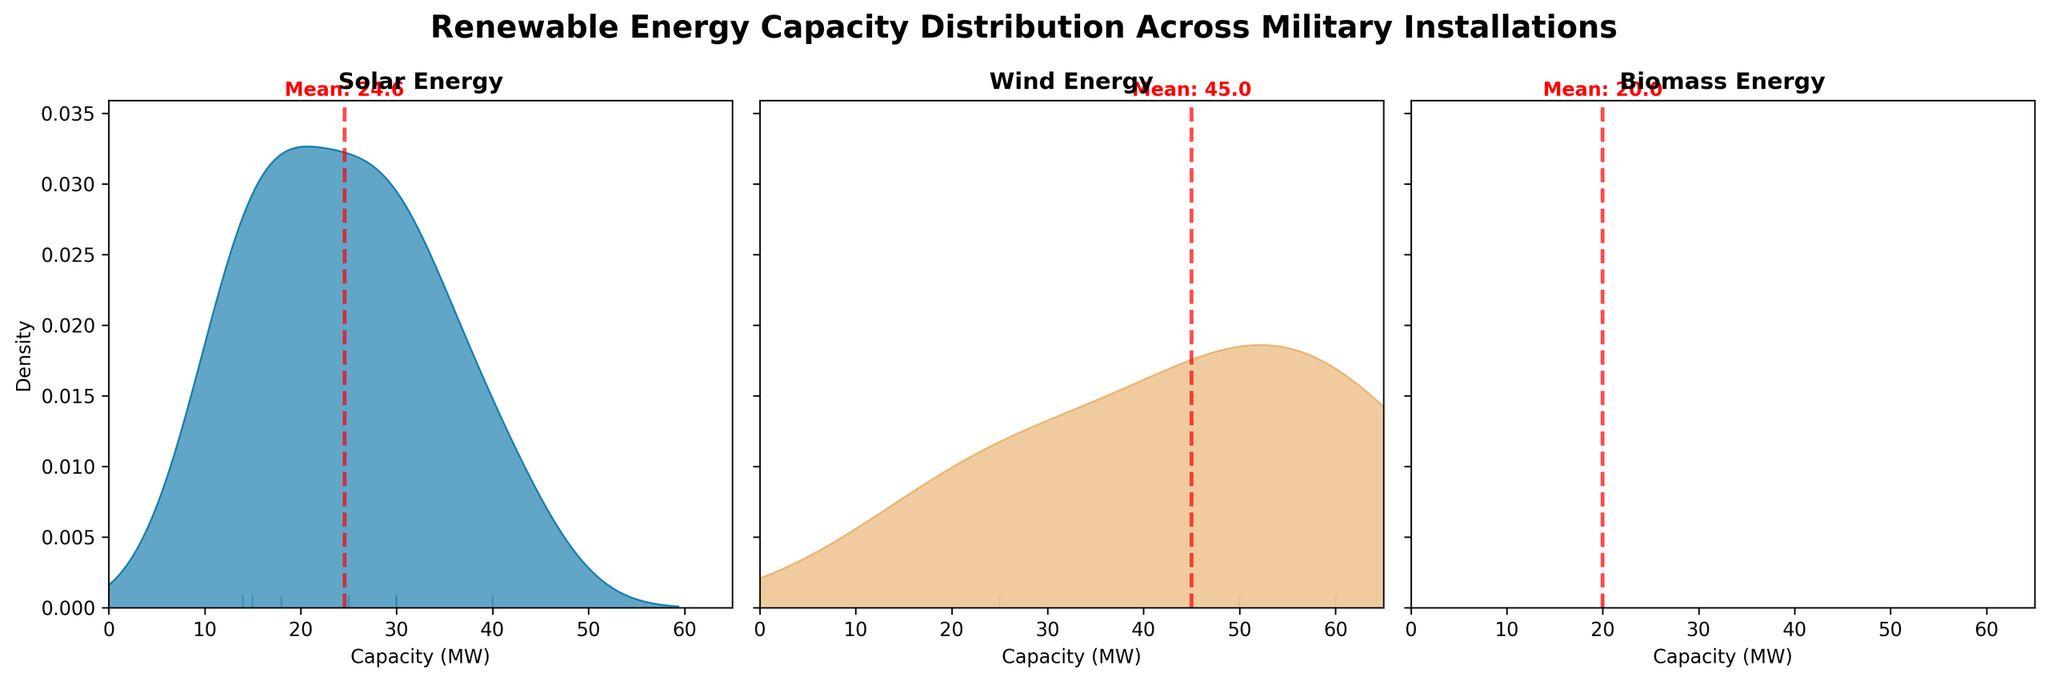What types of renewable energy sources are included in the density plots? The density plots display different renewable energy sources as labeled in the titles: Solar, Wind, and Biomass. By observing the titles of the subplots, we can see they are labeled "Solar Energy," "Wind Energy," and "Biomass Energy."
Answer: Solar, Wind, Biomass How is the average capacity represented in the density plots? In each density plot, the average capacity for that renewable energy source is represented by a red dashed vertical line with a text annotation indicating "Mean: [value]." This can be seen clearly for each type of energy in their respective subplots.
Answer: Red dashed line Which renewable energy source has the highest average capacity? To determine the renewable energy source with the highest average capacity, we compare the mean values indicated by the red dashed lines in each plot. The mean capacity for Wind is the highest, as marked on the respective plot.
Answer: Wind What is the mean capacity for Solar energy? The mean capacity is shown by the red dashed vertical line in the Solar energy plot. The text annotation next to this line reads "Mean: 24.6," indicating that the mean capacity for Solar energy is 24.6 MW.
Answer: 24.6 MW How does the distribution of capacity for Biomass compare to Solar? By looking at the density plots, the capacity distribution for Biomass is narrower and more concentrated around the lower MW values compared to Solar, which shows a wider distribution with peaks around different values.
Answer: Biomass is narrower, more concentrated Which energy type shows the widest range of capacity values? The energy type with the widest range of capacity values can be identified by the spread of the density plot. Wind shows the widest range, as the plot extends from around 25 MW to 60 MW.
Answer: Wind What does the shading under the curve in the density plots represent? The shading under the curve in the density plots represents the probability density of installations with different capacities. Darker shading indicates higher density, meaning more installations have those specific capacities.
Answer: Probability density Are there any outlier data points in the density plots? Rug plots at the bottom of each density plot show individual capacity data points. In the Wind plot, there are points away from the main cluster which could be considered as outliers. These data points lie far from the dense region under the curve.
Answer: Yes, in Wind How many installations have a capacity around 40 MW for Wind energy? The rug plot below the Wind density plot shows individual capacity data points. Observing the spikes around the 40 MW mark can give an approximate number of installations. There are no spikes around 40 MW in the Wind density plot, indicating there are no installations with around 40 MW.
Answer: None 